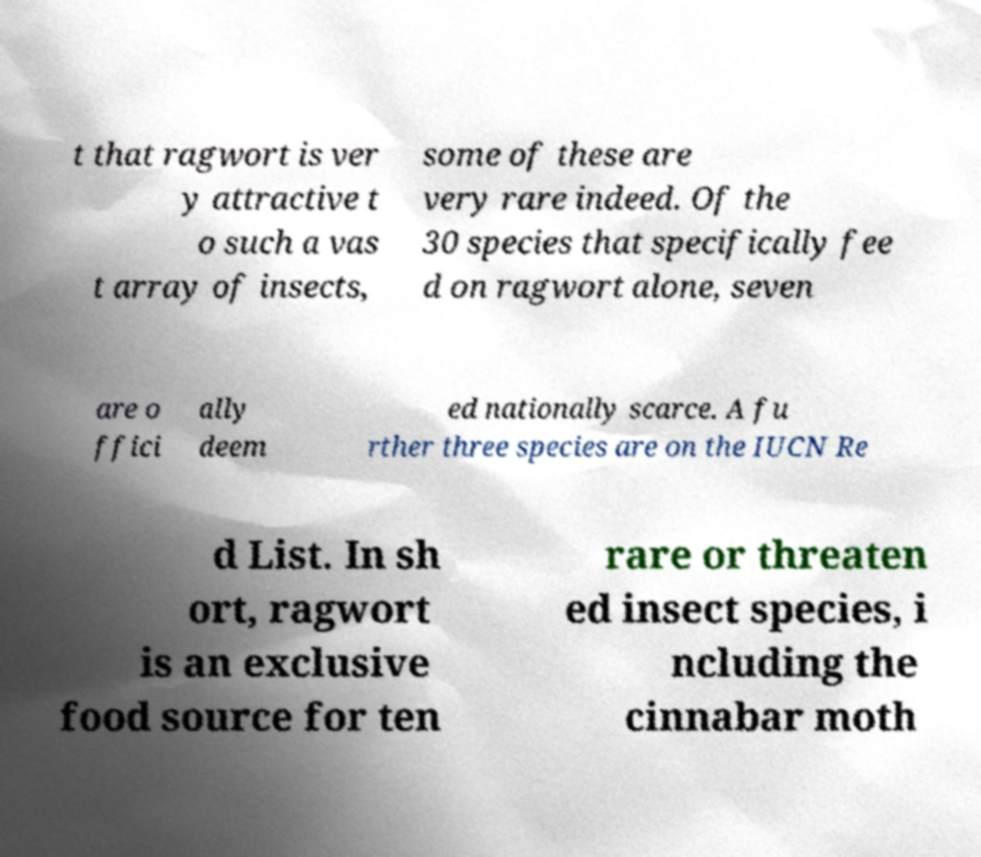Please identify and transcribe the text found in this image. t that ragwort is ver y attractive t o such a vas t array of insects, some of these are very rare indeed. Of the 30 species that specifically fee d on ragwort alone, seven are o ffici ally deem ed nationally scarce. A fu rther three species are on the IUCN Re d List. In sh ort, ragwort is an exclusive food source for ten rare or threaten ed insect species, i ncluding the cinnabar moth 